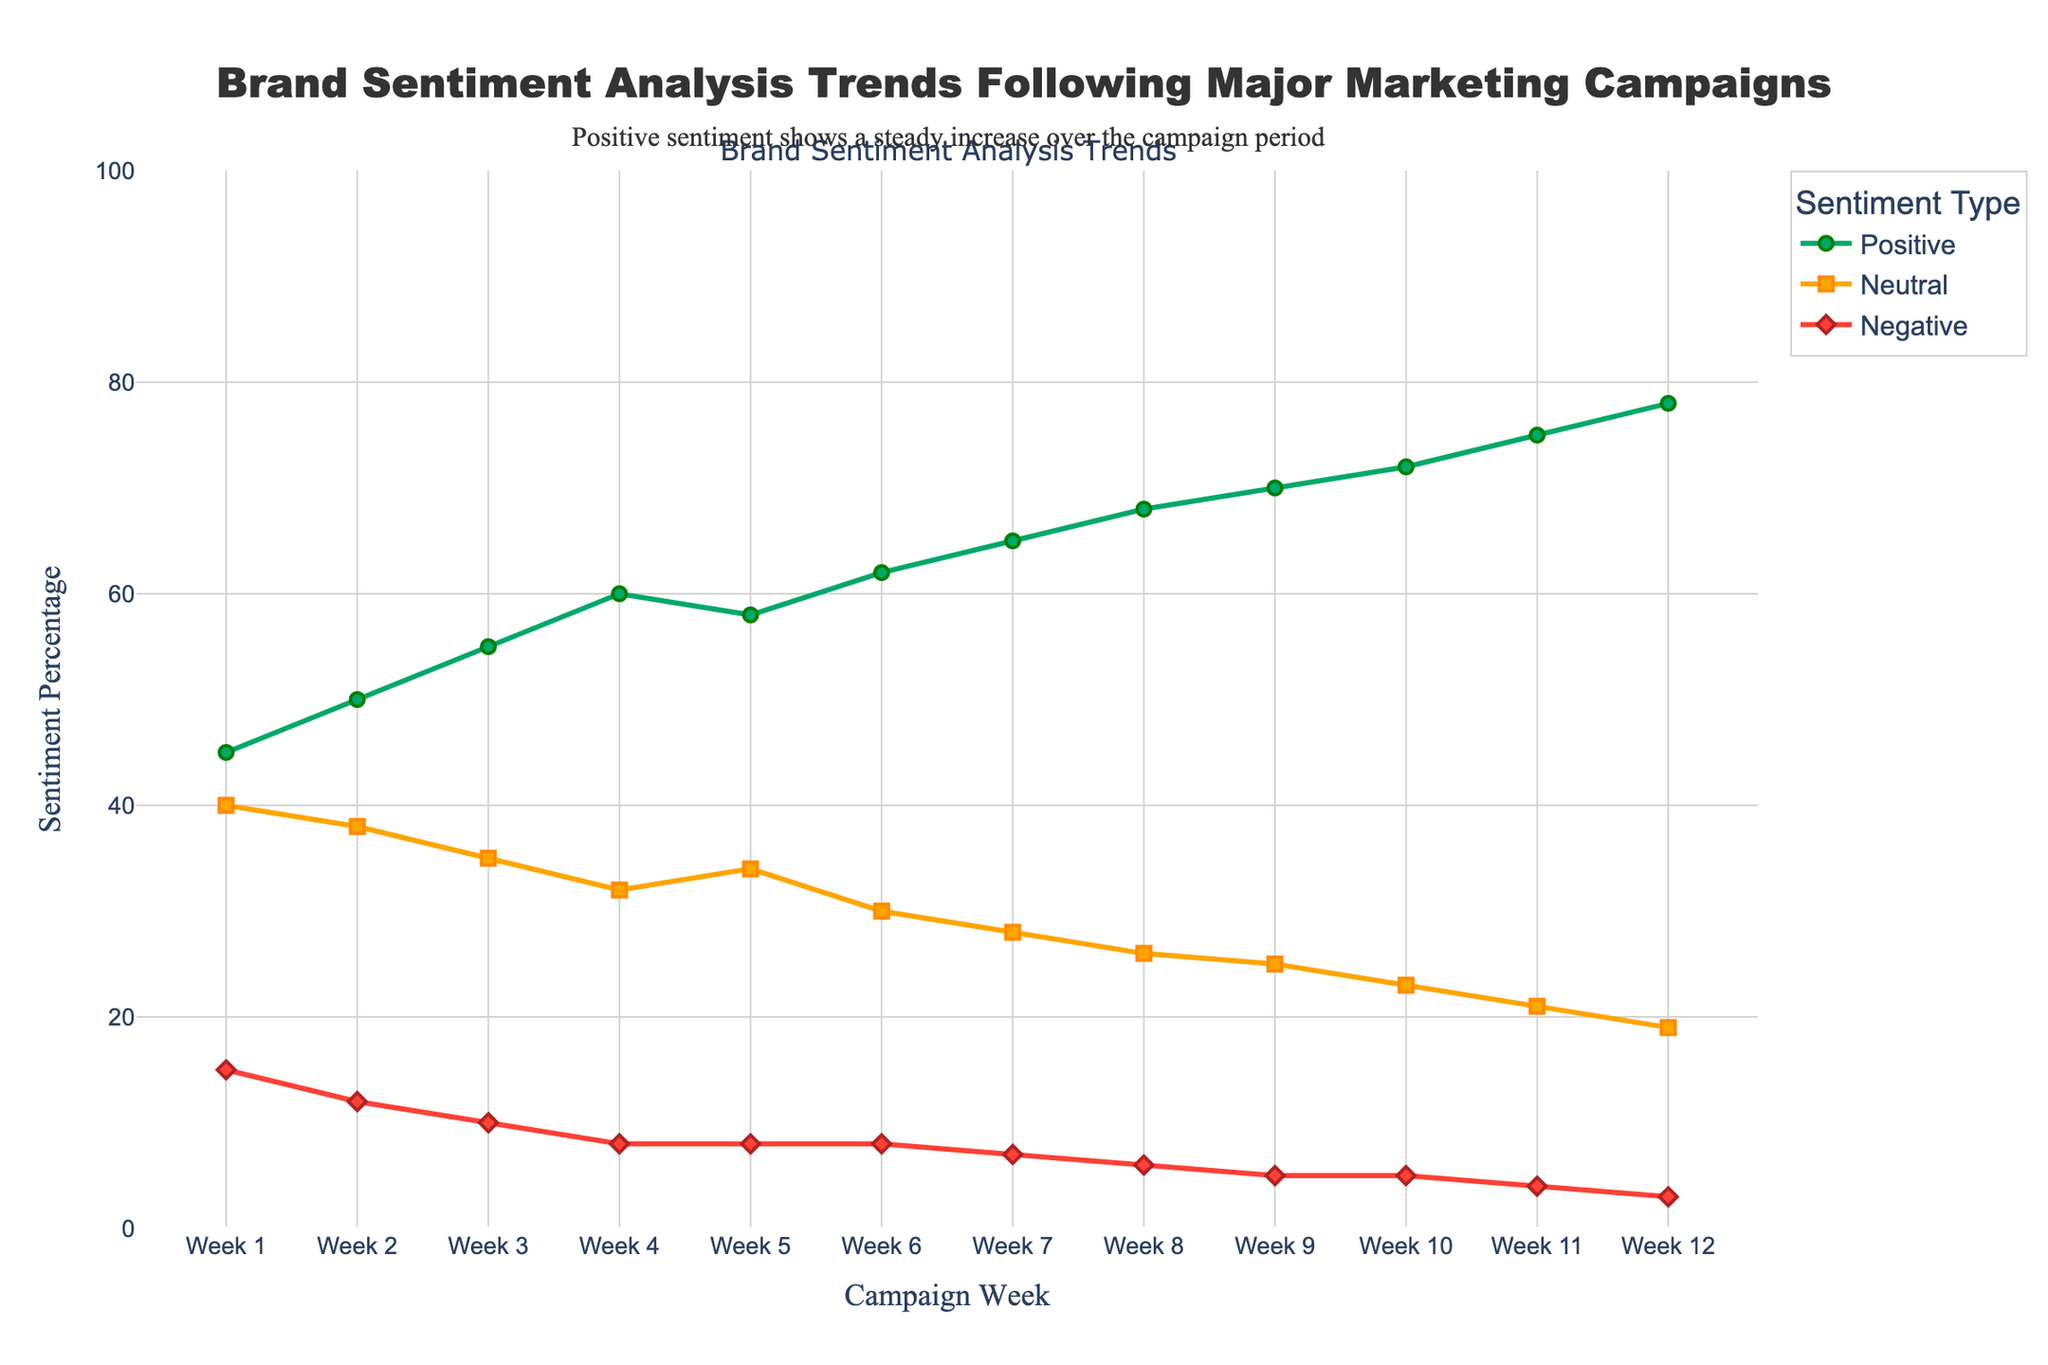What is the trend of positive sentiment throughout the campaign period? By observing the green line representing positive sentiment, it steadily increases from Week 1 (45%) to Week 12 (78%).
Answer: Positive sentiment increases In which week does negative sentiment become less than 10% for the first time? By looking at the red line representing negative sentiment, it is first below 10% in Week 3 (10%).
Answer: Week 3 How does neutral sentiment change from Week 5 to Week 8? The orange line representing neutral sentiment drops from 34% in Week 5 to 26% in Week 8.
Answer: Decreases from 34% to 26% Which week shows the highest positive sentiment, and what is its value? The green line peaks at Week 12, reaching 78%.
Answer: Week 12, 78% By what percentage did negative sentiment decrease from Week 1 to Week 12? The red line shows negative sentiment starts at 15% in Week 1 and descends to 3% in Week 12, a difference of 15% - 3% = 12%.
Answer: 12% Compare trends in positive and negative sentiment from Week 6 to Week 8. From the figure, positive sentiment rises from 62% to 68%, while negative sentiment decreases from 8% to 6%.
Answer: Positive increases, negative decreases Calculate the average neutral sentiment over the 12 weeks. Adding all neutral sentiment percentages from each week: (40+38+35+32+34+30+28+26+25+23+21+19) = 351. Dividing by 12 weeks gives 351/12 ≈ 29.25%.
Answer: 29.25% In which week do all three sentiments add up to exactly 100%? By examining the figure, all percentages of Week 4 (60% positive, 32% neutral, 8% negative) add up to 100%.
Answer: Week 4 Is there any week where neutral sentiment remains constant? The orange line for neutral sentiment remains the same at 8% from Week 4 to Week 6 and at 8% from Week 8 to Week 12.
Answer: No week has constant neutral sentiment 